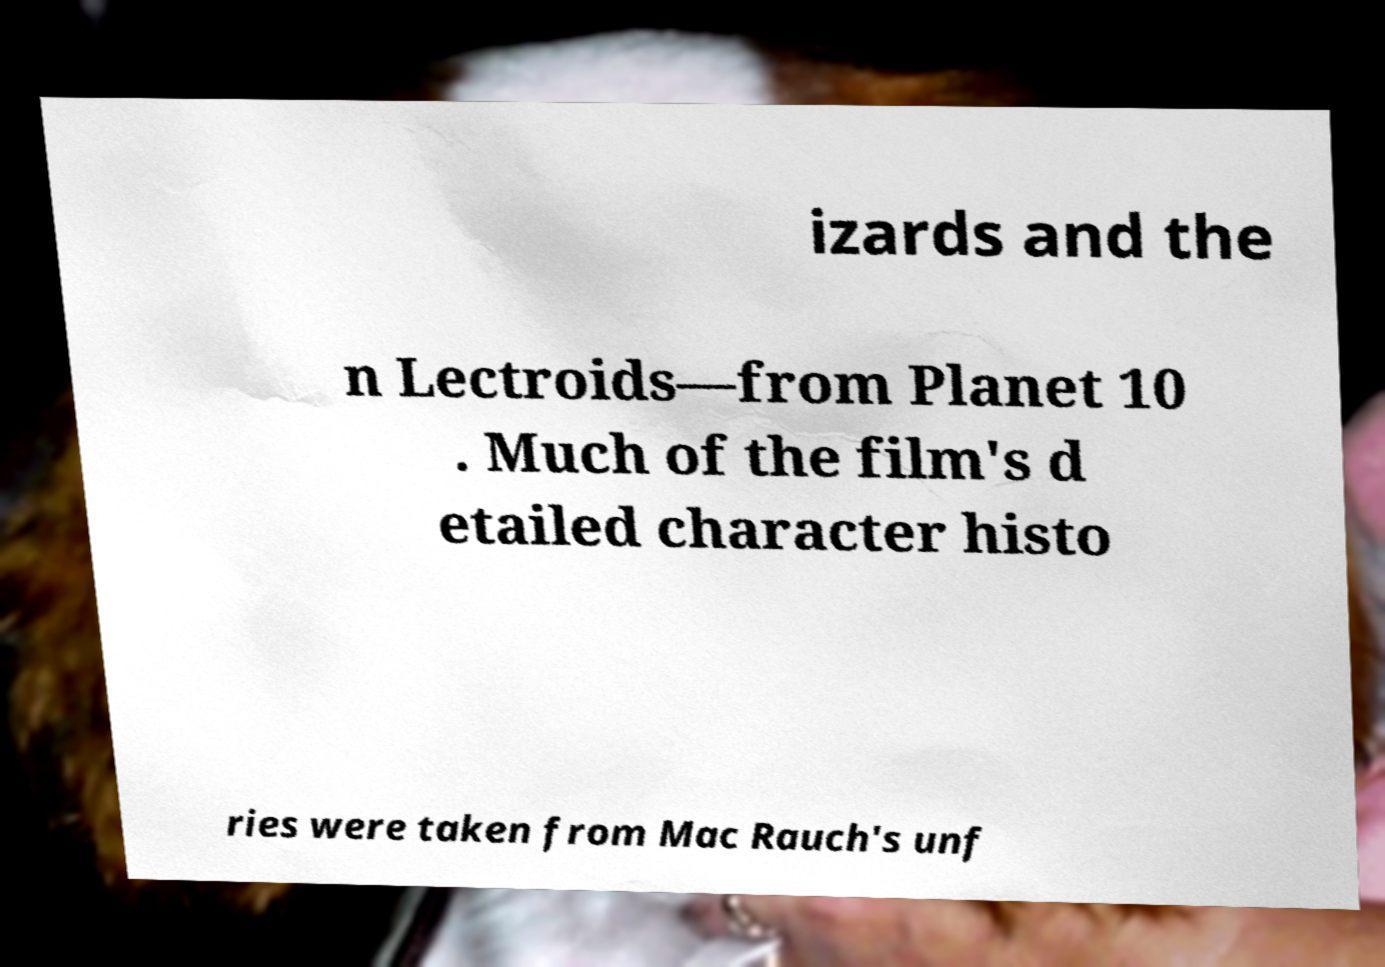What messages or text are displayed in this image? I need them in a readable, typed format. izards and the n Lectroids—from Planet 10 . Much of the film's d etailed character histo ries were taken from Mac Rauch's unf 